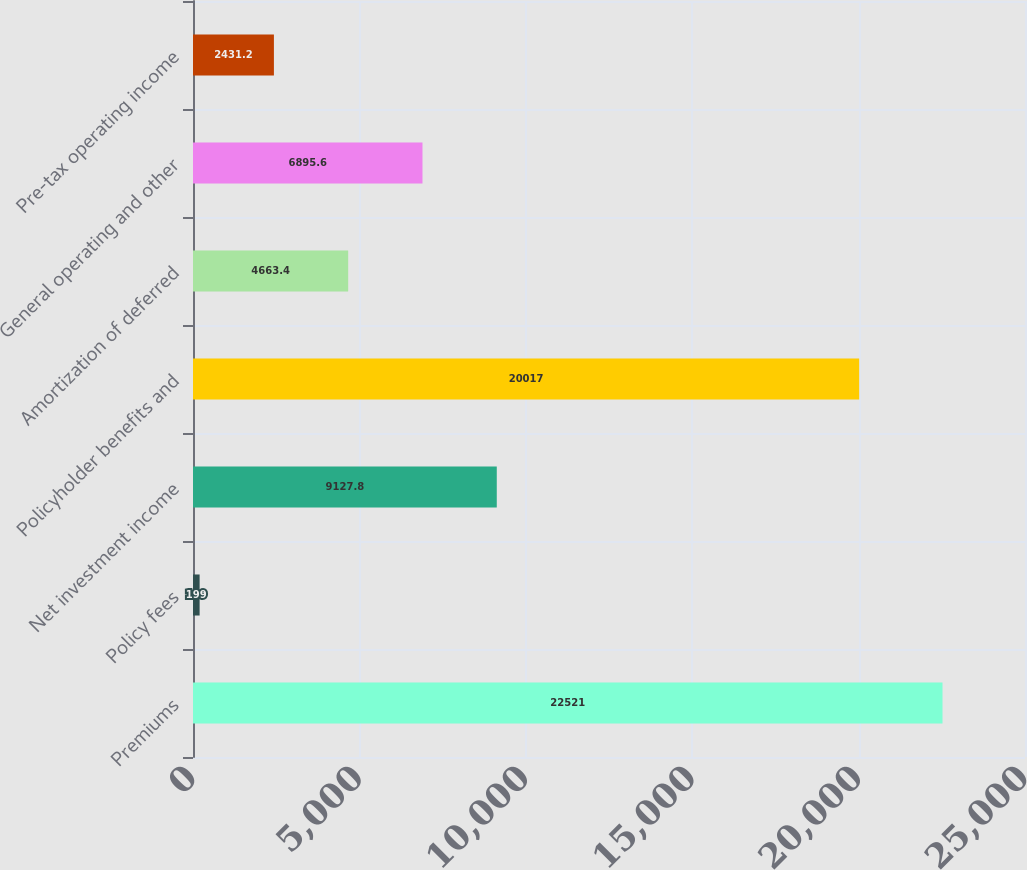Convert chart to OTSL. <chart><loc_0><loc_0><loc_500><loc_500><bar_chart><fcel>Premiums<fcel>Policy fees<fcel>Net investment income<fcel>Policyholder benefits and<fcel>Amortization of deferred<fcel>General operating and other<fcel>Pre-tax operating income<nl><fcel>22521<fcel>199<fcel>9127.8<fcel>20017<fcel>4663.4<fcel>6895.6<fcel>2431.2<nl></chart> 